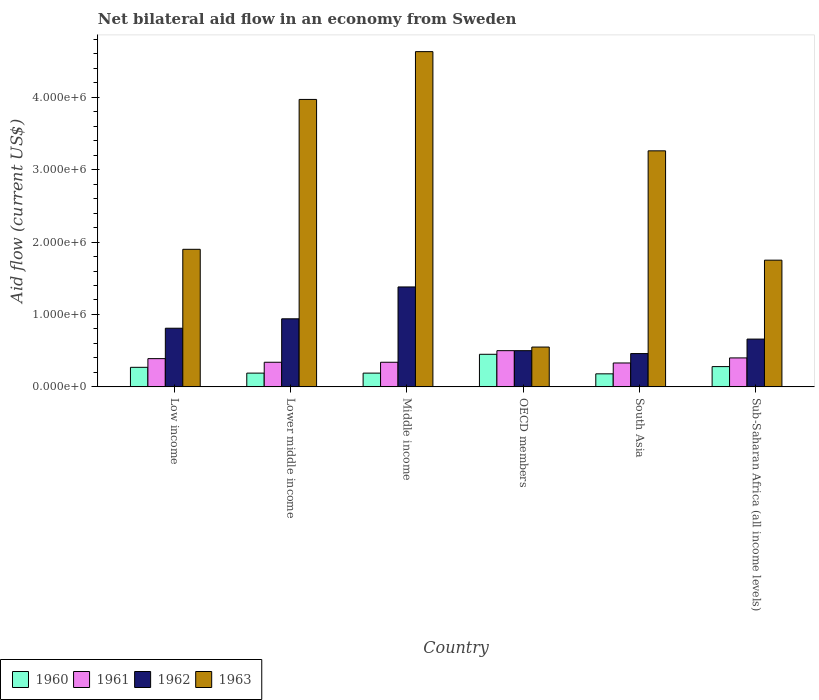How many different coloured bars are there?
Keep it short and to the point. 4. How many groups of bars are there?
Give a very brief answer. 6. How many bars are there on the 5th tick from the left?
Make the answer very short. 4. How many bars are there on the 1st tick from the right?
Provide a short and direct response. 4. In how many cases, is the number of bars for a given country not equal to the number of legend labels?
Make the answer very short. 0. What is the net bilateral aid flow in 1961 in Middle income?
Your answer should be very brief. 3.40e+05. Across all countries, what is the maximum net bilateral aid flow in 1963?
Offer a very short reply. 4.63e+06. Across all countries, what is the minimum net bilateral aid flow in 1960?
Offer a terse response. 1.80e+05. In which country was the net bilateral aid flow in 1962 minimum?
Your answer should be very brief. South Asia. What is the total net bilateral aid flow in 1962 in the graph?
Offer a very short reply. 4.75e+06. What is the difference between the net bilateral aid flow in 1960 in Low income and that in Middle income?
Keep it short and to the point. 8.00e+04. What is the difference between the net bilateral aid flow of/in 1963 and net bilateral aid flow of/in 1962 in Low income?
Provide a short and direct response. 1.09e+06. What is the ratio of the net bilateral aid flow in 1962 in Low income to that in Sub-Saharan Africa (all income levels)?
Provide a succinct answer. 1.23. Is the net bilateral aid flow in 1960 in Middle income less than that in South Asia?
Ensure brevity in your answer.  No. Is the difference between the net bilateral aid flow in 1963 in South Asia and Sub-Saharan Africa (all income levels) greater than the difference between the net bilateral aid flow in 1962 in South Asia and Sub-Saharan Africa (all income levels)?
Provide a succinct answer. Yes. What is the difference between the highest and the second highest net bilateral aid flow in 1961?
Offer a terse response. 1.10e+05. In how many countries, is the net bilateral aid flow in 1960 greater than the average net bilateral aid flow in 1960 taken over all countries?
Offer a very short reply. 3. Is it the case that in every country, the sum of the net bilateral aid flow in 1961 and net bilateral aid flow in 1962 is greater than the sum of net bilateral aid flow in 1963 and net bilateral aid flow in 1960?
Offer a terse response. No. What does the 3rd bar from the left in South Asia represents?
Your response must be concise. 1962. What does the 3rd bar from the right in Middle income represents?
Your answer should be compact. 1961. How many bars are there?
Provide a short and direct response. 24. How many countries are there in the graph?
Keep it short and to the point. 6. Are the values on the major ticks of Y-axis written in scientific E-notation?
Ensure brevity in your answer.  Yes. Does the graph contain any zero values?
Ensure brevity in your answer.  No. Does the graph contain grids?
Provide a short and direct response. No. How many legend labels are there?
Provide a short and direct response. 4. How are the legend labels stacked?
Offer a terse response. Horizontal. What is the title of the graph?
Provide a succinct answer. Net bilateral aid flow in an economy from Sweden. Does "1963" appear as one of the legend labels in the graph?
Give a very brief answer. Yes. What is the label or title of the X-axis?
Offer a very short reply. Country. What is the label or title of the Y-axis?
Ensure brevity in your answer.  Aid flow (current US$). What is the Aid flow (current US$) of 1960 in Low income?
Give a very brief answer. 2.70e+05. What is the Aid flow (current US$) in 1961 in Low income?
Offer a terse response. 3.90e+05. What is the Aid flow (current US$) of 1962 in Low income?
Provide a succinct answer. 8.10e+05. What is the Aid flow (current US$) in 1963 in Low income?
Provide a succinct answer. 1.90e+06. What is the Aid flow (current US$) of 1960 in Lower middle income?
Your answer should be very brief. 1.90e+05. What is the Aid flow (current US$) of 1961 in Lower middle income?
Your answer should be compact. 3.40e+05. What is the Aid flow (current US$) in 1962 in Lower middle income?
Keep it short and to the point. 9.40e+05. What is the Aid flow (current US$) in 1963 in Lower middle income?
Make the answer very short. 3.97e+06. What is the Aid flow (current US$) of 1960 in Middle income?
Your answer should be compact. 1.90e+05. What is the Aid flow (current US$) of 1961 in Middle income?
Give a very brief answer. 3.40e+05. What is the Aid flow (current US$) in 1962 in Middle income?
Ensure brevity in your answer.  1.38e+06. What is the Aid flow (current US$) of 1963 in Middle income?
Give a very brief answer. 4.63e+06. What is the Aid flow (current US$) in 1962 in OECD members?
Offer a very short reply. 5.00e+05. What is the Aid flow (current US$) of 1963 in OECD members?
Offer a terse response. 5.50e+05. What is the Aid flow (current US$) of 1960 in South Asia?
Offer a terse response. 1.80e+05. What is the Aid flow (current US$) of 1962 in South Asia?
Give a very brief answer. 4.60e+05. What is the Aid flow (current US$) of 1963 in South Asia?
Ensure brevity in your answer.  3.26e+06. What is the Aid flow (current US$) in 1960 in Sub-Saharan Africa (all income levels)?
Offer a very short reply. 2.80e+05. What is the Aid flow (current US$) in 1961 in Sub-Saharan Africa (all income levels)?
Make the answer very short. 4.00e+05. What is the Aid flow (current US$) in 1962 in Sub-Saharan Africa (all income levels)?
Give a very brief answer. 6.60e+05. What is the Aid flow (current US$) in 1963 in Sub-Saharan Africa (all income levels)?
Keep it short and to the point. 1.75e+06. Across all countries, what is the maximum Aid flow (current US$) of 1960?
Your response must be concise. 4.50e+05. Across all countries, what is the maximum Aid flow (current US$) in 1961?
Provide a short and direct response. 5.00e+05. Across all countries, what is the maximum Aid flow (current US$) in 1962?
Provide a short and direct response. 1.38e+06. Across all countries, what is the maximum Aid flow (current US$) of 1963?
Ensure brevity in your answer.  4.63e+06. What is the total Aid flow (current US$) in 1960 in the graph?
Offer a terse response. 1.56e+06. What is the total Aid flow (current US$) in 1961 in the graph?
Provide a short and direct response. 2.30e+06. What is the total Aid flow (current US$) in 1962 in the graph?
Your answer should be very brief. 4.75e+06. What is the total Aid flow (current US$) of 1963 in the graph?
Keep it short and to the point. 1.61e+07. What is the difference between the Aid flow (current US$) of 1963 in Low income and that in Lower middle income?
Ensure brevity in your answer.  -2.07e+06. What is the difference between the Aid flow (current US$) in 1961 in Low income and that in Middle income?
Your response must be concise. 5.00e+04. What is the difference between the Aid flow (current US$) of 1962 in Low income and that in Middle income?
Your response must be concise. -5.70e+05. What is the difference between the Aid flow (current US$) in 1963 in Low income and that in Middle income?
Give a very brief answer. -2.73e+06. What is the difference between the Aid flow (current US$) of 1961 in Low income and that in OECD members?
Keep it short and to the point. -1.10e+05. What is the difference between the Aid flow (current US$) of 1963 in Low income and that in OECD members?
Make the answer very short. 1.35e+06. What is the difference between the Aid flow (current US$) in 1961 in Low income and that in South Asia?
Offer a terse response. 6.00e+04. What is the difference between the Aid flow (current US$) in 1962 in Low income and that in South Asia?
Your answer should be compact. 3.50e+05. What is the difference between the Aid flow (current US$) in 1963 in Low income and that in South Asia?
Offer a very short reply. -1.36e+06. What is the difference between the Aid flow (current US$) of 1960 in Low income and that in Sub-Saharan Africa (all income levels)?
Ensure brevity in your answer.  -10000. What is the difference between the Aid flow (current US$) of 1961 in Low income and that in Sub-Saharan Africa (all income levels)?
Your answer should be very brief. -10000. What is the difference between the Aid flow (current US$) of 1960 in Lower middle income and that in Middle income?
Offer a very short reply. 0. What is the difference between the Aid flow (current US$) in 1962 in Lower middle income and that in Middle income?
Your answer should be very brief. -4.40e+05. What is the difference between the Aid flow (current US$) of 1963 in Lower middle income and that in Middle income?
Keep it short and to the point. -6.60e+05. What is the difference between the Aid flow (current US$) of 1960 in Lower middle income and that in OECD members?
Your answer should be compact. -2.60e+05. What is the difference between the Aid flow (current US$) in 1961 in Lower middle income and that in OECD members?
Your response must be concise. -1.60e+05. What is the difference between the Aid flow (current US$) in 1962 in Lower middle income and that in OECD members?
Your response must be concise. 4.40e+05. What is the difference between the Aid flow (current US$) in 1963 in Lower middle income and that in OECD members?
Ensure brevity in your answer.  3.42e+06. What is the difference between the Aid flow (current US$) of 1960 in Lower middle income and that in South Asia?
Your answer should be compact. 10000. What is the difference between the Aid flow (current US$) of 1962 in Lower middle income and that in South Asia?
Your response must be concise. 4.80e+05. What is the difference between the Aid flow (current US$) of 1963 in Lower middle income and that in South Asia?
Your answer should be very brief. 7.10e+05. What is the difference between the Aid flow (current US$) of 1961 in Lower middle income and that in Sub-Saharan Africa (all income levels)?
Make the answer very short. -6.00e+04. What is the difference between the Aid flow (current US$) in 1962 in Lower middle income and that in Sub-Saharan Africa (all income levels)?
Your response must be concise. 2.80e+05. What is the difference between the Aid flow (current US$) in 1963 in Lower middle income and that in Sub-Saharan Africa (all income levels)?
Make the answer very short. 2.22e+06. What is the difference between the Aid flow (current US$) in 1961 in Middle income and that in OECD members?
Provide a short and direct response. -1.60e+05. What is the difference between the Aid flow (current US$) in 1962 in Middle income and that in OECD members?
Your response must be concise. 8.80e+05. What is the difference between the Aid flow (current US$) of 1963 in Middle income and that in OECD members?
Ensure brevity in your answer.  4.08e+06. What is the difference between the Aid flow (current US$) in 1961 in Middle income and that in South Asia?
Your response must be concise. 10000. What is the difference between the Aid flow (current US$) of 1962 in Middle income and that in South Asia?
Give a very brief answer. 9.20e+05. What is the difference between the Aid flow (current US$) in 1963 in Middle income and that in South Asia?
Provide a succinct answer. 1.37e+06. What is the difference between the Aid flow (current US$) of 1960 in Middle income and that in Sub-Saharan Africa (all income levels)?
Your answer should be very brief. -9.00e+04. What is the difference between the Aid flow (current US$) in 1961 in Middle income and that in Sub-Saharan Africa (all income levels)?
Keep it short and to the point. -6.00e+04. What is the difference between the Aid flow (current US$) of 1962 in Middle income and that in Sub-Saharan Africa (all income levels)?
Your answer should be compact. 7.20e+05. What is the difference between the Aid flow (current US$) in 1963 in Middle income and that in Sub-Saharan Africa (all income levels)?
Ensure brevity in your answer.  2.88e+06. What is the difference between the Aid flow (current US$) in 1963 in OECD members and that in South Asia?
Make the answer very short. -2.71e+06. What is the difference between the Aid flow (current US$) of 1961 in OECD members and that in Sub-Saharan Africa (all income levels)?
Offer a very short reply. 1.00e+05. What is the difference between the Aid flow (current US$) in 1962 in OECD members and that in Sub-Saharan Africa (all income levels)?
Provide a succinct answer. -1.60e+05. What is the difference between the Aid flow (current US$) of 1963 in OECD members and that in Sub-Saharan Africa (all income levels)?
Your answer should be compact. -1.20e+06. What is the difference between the Aid flow (current US$) in 1960 in South Asia and that in Sub-Saharan Africa (all income levels)?
Ensure brevity in your answer.  -1.00e+05. What is the difference between the Aid flow (current US$) of 1961 in South Asia and that in Sub-Saharan Africa (all income levels)?
Offer a very short reply. -7.00e+04. What is the difference between the Aid flow (current US$) of 1962 in South Asia and that in Sub-Saharan Africa (all income levels)?
Your response must be concise. -2.00e+05. What is the difference between the Aid flow (current US$) of 1963 in South Asia and that in Sub-Saharan Africa (all income levels)?
Your answer should be compact. 1.51e+06. What is the difference between the Aid flow (current US$) of 1960 in Low income and the Aid flow (current US$) of 1961 in Lower middle income?
Your answer should be compact. -7.00e+04. What is the difference between the Aid flow (current US$) in 1960 in Low income and the Aid flow (current US$) in 1962 in Lower middle income?
Keep it short and to the point. -6.70e+05. What is the difference between the Aid flow (current US$) of 1960 in Low income and the Aid flow (current US$) of 1963 in Lower middle income?
Your response must be concise. -3.70e+06. What is the difference between the Aid flow (current US$) of 1961 in Low income and the Aid flow (current US$) of 1962 in Lower middle income?
Make the answer very short. -5.50e+05. What is the difference between the Aid flow (current US$) of 1961 in Low income and the Aid flow (current US$) of 1963 in Lower middle income?
Your response must be concise. -3.58e+06. What is the difference between the Aid flow (current US$) of 1962 in Low income and the Aid flow (current US$) of 1963 in Lower middle income?
Make the answer very short. -3.16e+06. What is the difference between the Aid flow (current US$) of 1960 in Low income and the Aid flow (current US$) of 1961 in Middle income?
Provide a succinct answer. -7.00e+04. What is the difference between the Aid flow (current US$) in 1960 in Low income and the Aid flow (current US$) in 1962 in Middle income?
Offer a terse response. -1.11e+06. What is the difference between the Aid flow (current US$) in 1960 in Low income and the Aid flow (current US$) in 1963 in Middle income?
Your answer should be very brief. -4.36e+06. What is the difference between the Aid flow (current US$) of 1961 in Low income and the Aid flow (current US$) of 1962 in Middle income?
Provide a succinct answer. -9.90e+05. What is the difference between the Aid flow (current US$) of 1961 in Low income and the Aid flow (current US$) of 1963 in Middle income?
Your response must be concise. -4.24e+06. What is the difference between the Aid flow (current US$) in 1962 in Low income and the Aid flow (current US$) in 1963 in Middle income?
Provide a short and direct response. -3.82e+06. What is the difference between the Aid flow (current US$) of 1960 in Low income and the Aid flow (current US$) of 1963 in OECD members?
Give a very brief answer. -2.80e+05. What is the difference between the Aid flow (current US$) in 1962 in Low income and the Aid flow (current US$) in 1963 in OECD members?
Offer a very short reply. 2.60e+05. What is the difference between the Aid flow (current US$) of 1960 in Low income and the Aid flow (current US$) of 1962 in South Asia?
Give a very brief answer. -1.90e+05. What is the difference between the Aid flow (current US$) of 1960 in Low income and the Aid flow (current US$) of 1963 in South Asia?
Offer a terse response. -2.99e+06. What is the difference between the Aid flow (current US$) in 1961 in Low income and the Aid flow (current US$) in 1962 in South Asia?
Keep it short and to the point. -7.00e+04. What is the difference between the Aid flow (current US$) in 1961 in Low income and the Aid flow (current US$) in 1963 in South Asia?
Keep it short and to the point. -2.87e+06. What is the difference between the Aid flow (current US$) of 1962 in Low income and the Aid flow (current US$) of 1963 in South Asia?
Your answer should be very brief. -2.45e+06. What is the difference between the Aid flow (current US$) in 1960 in Low income and the Aid flow (current US$) in 1961 in Sub-Saharan Africa (all income levels)?
Your answer should be compact. -1.30e+05. What is the difference between the Aid flow (current US$) in 1960 in Low income and the Aid flow (current US$) in 1962 in Sub-Saharan Africa (all income levels)?
Provide a succinct answer. -3.90e+05. What is the difference between the Aid flow (current US$) of 1960 in Low income and the Aid flow (current US$) of 1963 in Sub-Saharan Africa (all income levels)?
Your answer should be compact. -1.48e+06. What is the difference between the Aid flow (current US$) in 1961 in Low income and the Aid flow (current US$) in 1963 in Sub-Saharan Africa (all income levels)?
Keep it short and to the point. -1.36e+06. What is the difference between the Aid flow (current US$) in 1962 in Low income and the Aid flow (current US$) in 1963 in Sub-Saharan Africa (all income levels)?
Your answer should be compact. -9.40e+05. What is the difference between the Aid flow (current US$) in 1960 in Lower middle income and the Aid flow (current US$) in 1962 in Middle income?
Your response must be concise. -1.19e+06. What is the difference between the Aid flow (current US$) of 1960 in Lower middle income and the Aid flow (current US$) of 1963 in Middle income?
Provide a succinct answer. -4.44e+06. What is the difference between the Aid flow (current US$) of 1961 in Lower middle income and the Aid flow (current US$) of 1962 in Middle income?
Make the answer very short. -1.04e+06. What is the difference between the Aid flow (current US$) of 1961 in Lower middle income and the Aid flow (current US$) of 1963 in Middle income?
Give a very brief answer. -4.29e+06. What is the difference between the Aid flow (current US$) in 1962 in Lower middle income and the Aid flow (current US$) in 1963 in Middle income?
Offer a very short reply. -3.69e+06. What is the difference between the Aid flow (current US$) of 1960 in Lower middle income and the Aid flow (current US$) of 1961 in OECD members?
Ensure brevity in your answer.  -3.10e+05. What is the difference between the Aid flow (current US$) of 1960 in Lower middle income and the Aid flow (current US$) of 1962 in OECD members?
Your response must be concise. -3.10e+05. What is the difference between the Aid flow (current US$) in 1960 in Lower middle income and the Aid flow (current US$) in 1963 in OECD members?
Your response must be concise. -3.60e+05. What is the difference between the Aid flow (current US$) in 1961 in Lower middle income and the Aid flow (current US$) in 1962 in OECD members?
Give a very brief answer. -1.60e+05. What is the difference between the Aid flow (current US$) of 1962 in Lower middle income and the Aid flow (current US$) of 1963 in OECD members?
Your response must be concise. 3.90e+05. What is the difference between the Aid flow (current US$) in 1960 in Lower middle income and the Aid flow (current US$) in 1961 in South Asia?
Your answer should be very brief. -1.40e+05. What is the difference between the Aid flow (current US$) in 1960 in Lower middle income and the Aid flow (current US$) in 1963 in South Asia?
Ensure brevity in your answer.  -3.07e+06. What is the difference between the Aid flow (current US$) of 1961 in Lower middle income and the Aid flow (current US$) of 1963 in South Asia?
Make the answer very short. -2.92e+06. What is the difference between the Aid flow (current US$) in 1962 in Lower middle income and the Aid flow (current US$) in 1963 in South Asia?
Offer a terse response. -2.32e+06. What is the difference between the Aid flow (current US$) in 1960 in Lower middle income and the Aid flow (current US$) in 1962 in Sub-Saharan Africa (all income levels)?
Your response must be concise. -4.70e+05. What is the difference between the Aid flow (current US$) of 1960 in Lower middle income and the Aid flow (current US$) of 1963 in Sub-Saharan Africa (all income levels)?
Offer a very short reply. -1.56e+06. What is the difference between the Aid flow (current US$) of 1961 in Lower middle income and the Aid flow (current US$) of 1962 in Sub-Saharan Africa (all income levels)?
Your answer should be compact. -3.20e+05. What is the difference between the Aid flow (current US$) of 1961 in Lower middle income and the Aid flow (current US$) of 1963 in Sub-Saharan Africa (all income levels)?
Keep it short and to the point. -1.41e+06. What is the difference between the Aid flow (current US$) in 1962 in Lower middle income and the Aid flow (current US$) in 1963 in Sub-Saharan Africa (all income levels)?
Keep it short and to the point. -8.10e+05. What is the difference between the Aid flow (current US$) in 1960 in Middle income and the Aid flow (current US$) in 1961 in OECD members?
Ensure brevity in your answer.  -3.10e+05. What is the difference between the Aid flow (current US$) of 1960 in Middle income and the Aid flow (current US$) of 1962 in OECD members?
Provide a succinct answer. -3.10e+05. What is the difference between the Aid flow (current US$) in 1960 in Middle income and the Aid flow (current US$) in 1963 in OECD members?
Ensure brevity in your answer.  -3.60e+05. What is the difference between the Aid flow (current US$) in 1961 in Middle income and the Aid flow (current US$) in 1963 in OECD members?
Give a very brief answer. -2.10e+05. What is the difference between the Aid flow (current US$) of 1962 in Middle income and the Aid flow (current US$) of 1963 in OECD members?
Your answer should be compact. 8.30e+05. What is the difference between the Aid flow (current US$) in 1960 in Middle income and the Aid flow (current US$) in 1963 in South Asia?
Give a very brief answer. -3.07e+06. What is the difference between the Aid flow (current US$) of 1961 in Middle income and the Aid flow (current US$) of 1963 in South Asia?
Provide a succinct answer. -2.92e+06. What is the difference between the Aid flow (current US$) of 1962 in Middle income and the Aid flow (current US$) of 1963 in South Asia?
Provide a succinct answer. -1.88e+06. What is the difference between the Aid flow (current US$) of 1960 in Middle income and the Aid flow (current US$) of 1961 in Sub-Saharan Africa (all income levels)?
Keep it short and to the point. -2.10e+05. What is the difference between the Aid flow (current US$) in 1960 in Middle income and the Aid flow (current US$) in 1962 in Sub-Saharan Africa (all income levels)?
Your answer should be very brief. -4.70e+05. What is the difference between the Aid flow (current US$) of 1960 in Middle income and the Aid flow (current US$) of 1963 in Sub-Saharan Africa (all income levels)?
Your answer should be compact. -1.56e+06. What is the difference between the Aid flow (current US$) of 1961 in Middle income and the Aid flow (current US$) of 1962 in Sub-Saharan Africa (all income levels)?
Your answer should be compact. -3.20e+05. What is the difference between the Aid flow (current US$) of 1961 in Middle income and the Aid flow (current US$) of 1963 in Sub-Saharan Africa (all income levels)?
Your answer should be compact. -1.41e+06. What is the difference between the Aid flow (current US$) in 1962 in Middle income and the Aid flow (current US$) in 1963 in Sub-Saharan Africa (all income levels)?
Your answer should be compact. -3.70e+05. What is the difference between the Aid flow (current US$) of 1960 in OECD members and the Aid flow (current US$) of 1961 in South Asia?
Give a very brief answer. 1.20e+05. What is the difference between the Aid flow (current US$) in 1960 in OECD members and the Aid flow (current US$) in 1962 in South Asia?
Make the answer very short. -10000. What is the difference between the Aid flow (current US$) of 1960 in OECD members and the Aid flow (current US$) of 1963 in South Asia?
Provide a short and direct response. -2.81e+06. What is the difference between the Aid flow (current US$) of 1961 in OECD members and the Aid flow (current US$) of 1962 in South Asia?
Make the answer very short. 4.00e+04. What is the difference between the Aid flow (current US$) in 1961 in OECD members and the Aid flow (current US$) in 1963 in South Asia?
Offer a terse response. -2.76e+06. What is the difference between the Aid flow (current US$) of 1962 in OECD members and the Aid flow (current US$) of 1963 in South Asia?
Offer a very short reply. -2.76e+06. What is the difference between the Aid flow (current US$) of 1960 in OECD members and the Aid flow (current US$) of 1961 in Sub-Saharan Africa (all income levels)?
Ensure brevity in your answer.  5.00e+04. What is the difference between the Aid flow (current US$) in 1960 in OECD members and the Aid flow (current US$) in 1962 in Sub-Saharan Africa (all income levels)?
Provide a short and direct response. -2.10e+05. What is the difference between the Aid flow (current US$) of 1960 in OECD members and the Aid flow (current US$) of 1963 in Sub-Saharan Africa (all income levels)?
Ensure brevity in your answer.  -1.30e+06. What is the difference between the Aid flow (current US$) in 1961 in OECD members and the Aid flow (current US$) in 1963 in Sub-Saharan Africa (all income levels)?
Your answer should be very brief. -1.25e+06. What is the difference between the Aid flow (current US$) of 1962 in OECD members and the Aid flow (current US$) of 1963 in Sub-Saharan Africa (all income levels)?
Your answer should be compact. -1.25e+06. What is the difference between the Aid flow (current US$) of 1960 in South Asia and the Aid flow (current US$) of 1962 in Sub-Saharan Africa (all income levels)?
Provide a short and direct response. -4.80e+05. What is the difference between the Aid flow (current US$) in 1960 in South Asia and the Aid flow (current US$) in 1963 in Sub-Saharan Africa (all income levels)?
Offer a terse response. -1.57e+06. What is the difference between the Aid flow (current US$) in 1961 in South Asia and the Aid flow (current US$) in 1962 in Sub-Saharan Africa (all income levels)?
Make the answer very short. -3.30e+05. What is the difference between the Aid flow (current US$) of 1961 in South Asia and the Aid flow (current US$) of 1963 in Sub-Saharan Africa (all income levels)?
Your answer should be very brief. -1.42e+06. What is the difference between the Aid flow (current US$) in 1962 in South Asia and the Aid flow (current US$) in 1963 in Sub-Saharan Africa (all income levels)?
Your answer should be very brief. -1.29e+06. What is the average Aid flow (current US$) of 1961 per country?
Your answer should be compact. 3.83e+05. What is the average Aid flow (current US$) of 1962 per country?
Provide a short and direct response. 7.92e+05. What is the average Aid flow (current US$) of 1963 per country?
Make the answer very short. 2.68e+06. What is the difference between the Aid flow (current US$) in 1960 and Aid flow (current US$) in 1961 in Low income?
Your answer should be compact. -1.20e+05. What is the difference between the Aid flow (current US$) of 1960 and Aid flow (current US$) of 1962 in Low income?
Your response must be concise. -5.40e+05. What is the difference between the Aid flow (current US$) in 1960 and Aid flow (current US$) in 1963 in Low income?
Provide a short and direct response. -1.63e+06. What is the difference between the Aid flow (current US$) of 1961 and Aid flow (current US$) of 1962 in Low income?
Your answer should be compact. -4.20e+05. What is the difference between the Aid flow (current US$) of 1961 and Aid flow (current US$) of 1963 in Low income?
Your answer should be compact. -1.51e+06. What is the difference between the Aid flow (current US$) in 1962 and Aid flow (current US$) in 1963 in Low income?
Your answer should be very brief. -1.09e+06. What is the difference between the Aid flow (current US$) in 1960 and Aid flow (current US$) in 1962 in Lower middle income?
Keep it short and to the point. -7.50e+05. What is the difference between the Aid flow (current US$) of 1960 and Aid flow (current US$) of 1963 in Lower middle income?
Provide a succinct answer. -3.78e+06. What is the difference between the Aid flow (current US$) in 1961 and Aid flow (current US$) in 1962 in Lower middle income?
Provide a short and direct response. -6.00e+05. What is the difference between the Aid flow (current US$) in 1961 and Aid flow (current US$) in 1963 in Lower middle income?
Your answer should be compact. -3.63e+06. What is the difference between the Aid flow (current US$) of 1962 and Aid flow (current US$) of 1963 in Lower middle income?
Make the answer very short. -3.03e+06. What is the difference between the Aid flow (current US$) of 1960 and Aid flow (current US$) of 1961 in Middle income?
Provide a succinct answer. -1.50e+05. What is the difference between the Aid flow (current US$) in 1960 and Aid flow (current US$) in 1962 in Middle income?
Give a very brief answer. -1.19e+06. What is the difference between the Aid flow (current US$) of 1960 and Aid flow (current US$) of 1963 in Middle income?
Make the answer very short. -4.44e+06. What is the difference between the Aid flow (current US$) in 1961 and Aid flow (current US$) in 1962 in Middle income?
Your response must be concise. -1.04e+06. What is the difference between the Aid flow (current US$) of 1961 and Aid flow (current US$) of 1963 in Middle income?
Provide a succinct answer. -4.29e+06. What is the difference between the Aid flow (current US$) of 1962 and Aid flow (current US$) of 1963 in Middle income?
Your response must be concise. -3.25e+06. What is the difference between the Aid flow (current US$) of 1960 and Aid flow (current US$) of 1961 in OECD members?
Keep it short and to the point. -5.00e+04. What is the difference between the Aid flow (current US$) in 1961 and Aid flow (current US$) in 1962 in OECD members?
Offer a very short reply. 0. What is the difference between the Aid flow (current US$) of 1960 and Aid flow (current US$) of 1961 in South Asia?
Offer a very short reply. -1.50e+05. What is the difference between the Aid flow (current US$) in 1960 and Aid flow (current US$) in 1962 in South Asia?
Give a very brief answer. -2.80e+05. What is the difference between the Aid flow (current US$) of 1960 and Aid flow (current US$) of 1963 in South Asia?
Offer a very short reply. -3.08e+06. What is the difference between the Aid flow (current US$) of 1961 and Aid flow (current US$) of 1963 in South Asia?
Offer a very short reply. -2.93e+06. What is the difference between the Aid flow (current US$) in 1962 and Aid flow (current US$) in 1963 in South Asia?
Your answer should be very brief. -2.80e+06. What is the difference between the Aid flow (current US$) of 1960 and Aid flow (current US$) of 1961 in Sub-Saharan Africa (all income levels)?
Offer a very short reply. -1.20e+05. What is the difference between the Aid flow (current US$) of 1960 and Aid flow (current US$) of 1962 in Sub-Saharan Africa (all income levels)?
Ensure brevity in your answer.  -3.80e+05. What is the difference between the Aid flow (current US$) in 1960 and Aid flow (current US$) in 1963 in Sub-Saharan Africa (all income levels)?
Your answer should be very brief. -1.47e+06. What is the difference between the Aid flow (current US$) in 1961 and Aid flow (current US$) in 1963 in Sub-Saharan Africa (all income levels)?
Make the answer very short. -1.35e+06. What is the difference between the Aid flow (current US$) in 1962 and Aid flow (current US$) in 1963 in Sub-Saharan Africa (all income levels)?
Provide a succinct answer. -1.09e+06. What is the ratio of the Aid flow (current US$) of 1960 in Low income to that in Lower middle income?
Your answer should be very brief. 1.42. What is the ratio of the Aid flow (current US$) in 1961 in Low income to that in Lower middle income?
Ensure brevity in your answer.  1.15. What is the ratio of the Aid flow (current US$) in 1962 in Low income to that in Lower middle income?
Ensure brevity in your answer.  0.86. What is the ratio of the Aid flow (current US$) in 1963 in Low income to that in Lower middle income?
Your answer should be compact. 0.48. What is the ratio of the Aid flow (current US$) in 1960 in Low income to that in Middle income?
Your answer should be very brief. 1.42. What is the ratio of the Aid flow (current US$) of 1961 in Low income to that in Middle income?
Offer a very short reply. 1.15. What is the ratio of the Aid flow (current US$) in 1962 in Low income to that in Middle income?
Provide a short and direct response. 0.59. What is the ratio of the Aid flow (current US$) of 1963 in Low income to that in Middle income?
Offer a very short reply. 0.41. What is the ratio of the Aid flow (current US$) of 1961 in Low income to that in OECD members?
Offer a terse response. 0.78. What is the ratio of the Aid flow (current US$) of 1962 in Low income to that in OECD members?
Your answer should be very brief. 1.62. What is the ratio of the Aid flow (current US$) of 1963 in Low income to that in OECD members?
Your answer should be very brief. 3.45. What is the ratio of the Aid flow (current US$) in 1960 in Low income to that in South Asia?
Provide a succinct answer. 1.5. What is the ratio of the Aid flow (current US$) of 1961 in Low income to that in South Asia?
Ensure brevity in your answer.  1.18. What is the ratio of the Aid flow (current US$) in 1962 in Low income to that in South Asia?
Your answer should be very brief. 1.76. What is the ratio of the Aid flow (current US$) of 1963 in Low income to that in South Asia?
Your answer should be very brief. 0.58. What is the ratio of the Aid flow (current US$) of 1961 in Low income to that in Sub-Saharan Africa (all income levels)?
Provide a short and direct response. 0.97. What is the ratio of the Aid flow (current US$) of 1962 in Low income to that in Sub-Saharan Africa (all income levels)?
Keep it short and to the point. 1.23. What is the ratio of the Aid flow (current US$) in 1963 in Low income to that in Sub-Saharan Africa (all income levels)?
Provide a short and direct response. 1.09. What is the ratio of the Aid flow (current US$) of 1960 in Lower middle income to that in Middle income?
Make the answer very short. 1. What is the ratio of the Aid flow (current US$) in 1962 in Lower middle income to that in Middle income?
Offer a terse response. 0.68. What is the ratio of the Aid flow (current US$) in 1963 in Lower middle income to that in Middle income?
Offer a terse response. 0.86. What is the ratio of the Aid flow (current US$) in 1960 in Lower middle income to that in OECD members?
Your answer should be compact. 0.42. What is the ratio of the Aid flow (current US$) of 1961 in Lower middle income to that in OECD members?
Your answer should be compact. 0.68. What is the ratio of the Aid flow (current US$) in 1962 in Lower middle income to that in OECD members?
Your answer should be compact. 1.88. What is the ratio of the Aid flow (current US$) in 1963 in Lower middle income to that in OECD members?
Offer a very short reply. 7.22. What is the ratio of the Aid flow (current US$) in 1960 in Lower middle income to that in South Asia?
Provide a short and direct response. 1.06. What is the ratio of the Aid flow (current US$) of 1961 in Lower middle income to that in South Asia?
Provide a short and direct response. 1.03. What is the ratio of the Aid flow (current US$) of 1962 in Lower middle income to that in South Asia?
Ensure brevity in your answer.  2.04. What is the ratio of the Aid flow (current US$) of 1963 in Lower middle income to that in South Asia?
Provide a succinct answer. 1.22. What is the ratio of the Aid flow (current US$) of 1960 in Lower middle income to that in Sub-Saharan Africa (all income levels)?
Ensure brevity in your answer.  0.68. What is the ratio of the Aid flow (current US$) of 1961 in Lower middle income to that in Sub-Saharan Africa (all income levels)?
Provide a short and direct response. 0.85. What is the ratio of the Aid flow (current US$) in 1962 in Lower middle income to that in Sub-Saharan Africa (all income levels)?
Give a very brief answer. 1.42. What is the ratio of the Aid flow (current US$) in 1963 in Lower middle income to that in Sub-Saharan Africa (all income levels)?
Your answer should be compact. 2.27. What is the ratio of the Aid flow (current US$) in 1960 in Middle income to that in OECD members?
Ensure brevity in your answer.  0.42. What is the ratio of the Aid flow (current US$) in 1961 in Middle income to that in OECD members?
Provide a short and direct response. 0.68. What is the ratio of the Aid flow (current US$) of 1962 in Middle income to that in OECD members?
Provide a short and direct response. 2.76. What is the ratio of the Aid flow (current US$) of 1963 in Middle income to that in OECD members?
Make the answer very short. 8.42. What is the ratio of the Aid flow (current US$) in 1960 in Middle income to that in South Asia?
Offer a very short reply. 1.06. What is the ratio of the Aid flow (current US$) in 1961 in Middle income to that in South Asia?
Ensure brevity in your answer.  1.03. What is the ratio of the Aid flow (current US$) in 1963 in Middle income to that in South Asia?
Ensure brevity in your answer.  1.42. What is the ratio of the Aid flow (current US$) of 1960 in Middle income to that in Sub-Saharan Africa (all income levels)?
Your response must be concise. 0.68. What is the ratio of the Aid flow (current US$) in 1962 in Middle income to that in Sub-Saharan Africa (all income levels)?
Provide a short and direct response. 2.09. What is the ratio of the Aid flow (current US$) of 1963 in Middle income to that in Sub-Saharan Africa (all income levels)?
Your answer should be very brief. 2.65. What is the ratio of the Aid flow (current US$) of 1960 in OECD members to that in South Asia?
Ensure brevity in your answer.  2.5. What is the ratio of the Aid flow (current US$) in 1961 in OECD members to that in South Asia?
Your answer should be very brief. 1.52. What is the ratio of the Aid flow (current US$) in 1962 in OECD members to that in South Asia?
Provide a succinct answer. 1.09. What is the ratio of the Aid flow (current US$) in 1963 in OECD members to that in South Asia?
Your response must be concise. 0.17. What is the ratio of the Aid flow (current US$) in 1960 in OECD members to that in Sub-Saharan Africa (all income levels)?
Provide a short and direct response. 1.61. What is the ratio of the Aid flow (current US$) of 1962 in OECD members to that in Sub-Saharan Africa (all income levels)?
Offer a terse response. 0.76. What is the ratio of the Aid flow (current US$) of 1963 in OECD members to that in Sub-Saharan Africa (all income levels)?
Your response must be concise. 0.31. What is the ratio of the Aid flow (current US$) in 1960 in South Asia to that in Sub-Saharan Africa (all income levels)?
Provide a short and direct response. 0.64. What is the ratio of the Aid flow (current US$) in 1961 in South Asia to that in Sub-Saharan Africa (all income levels)?
Provide a short and direct response. 0.82. What is the ratio of the Aid flow (current US$) of 1962 in South Asia to that in Sub-Saharan Africa (all income levels)?
Ensure brevity in your answer.  0.7. What is the ratio of the Aid flow (current US$) in 1963 in South Asia to that in Sub-Saharan Africa (all income levels)?
Make the answer very short. 1.86. What is the difference between the highest and the second highest Aid flow (current US$) in 1961?
Your response must be concise. 1.00e+05. What is the difference between the highest and the lowest Aid flow (current US$) in 1960?
Keep it short and to the point. 2.70e+05. What is the difference between the highest and the lowest Aid flow (current US$) in 1961?
Offer a terse response. 1.70e+05. What is the difference between the highest and the lowest Aid flow (current US$) of 1962?
Your answer should be compact. 9.20e+05. What is the difference between the highest and the lowest Aid flow (current US$) of 1963?
Make the answer very short. 4.08e+06. 